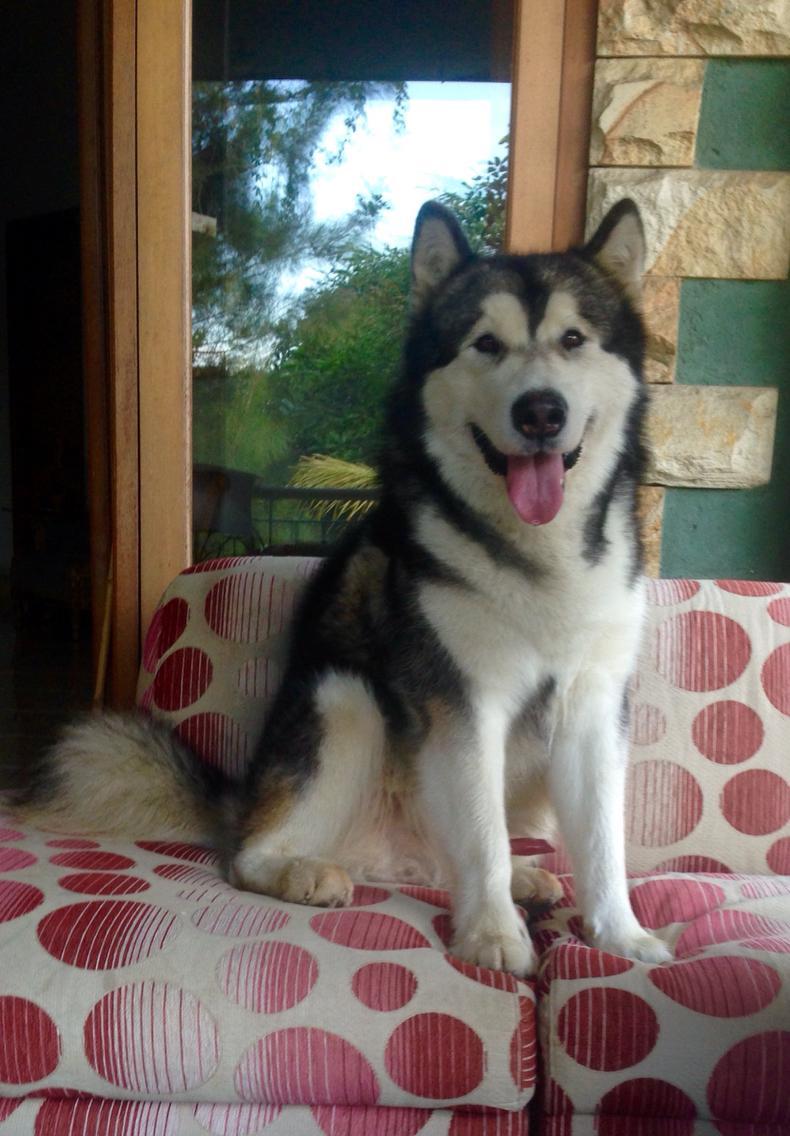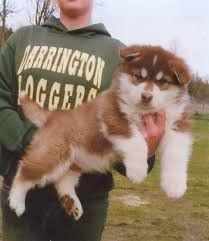The first image is the image on the left, the second image is the image on the right. Considering the images on both sides, is "There are dogs standing." valid? Answer yes or no. No. The first image is the image on the left, the second image is the image on the right. For the images shown, is this caption "There are two dogs in the image pair" true? Answer yes or no. Yes. 